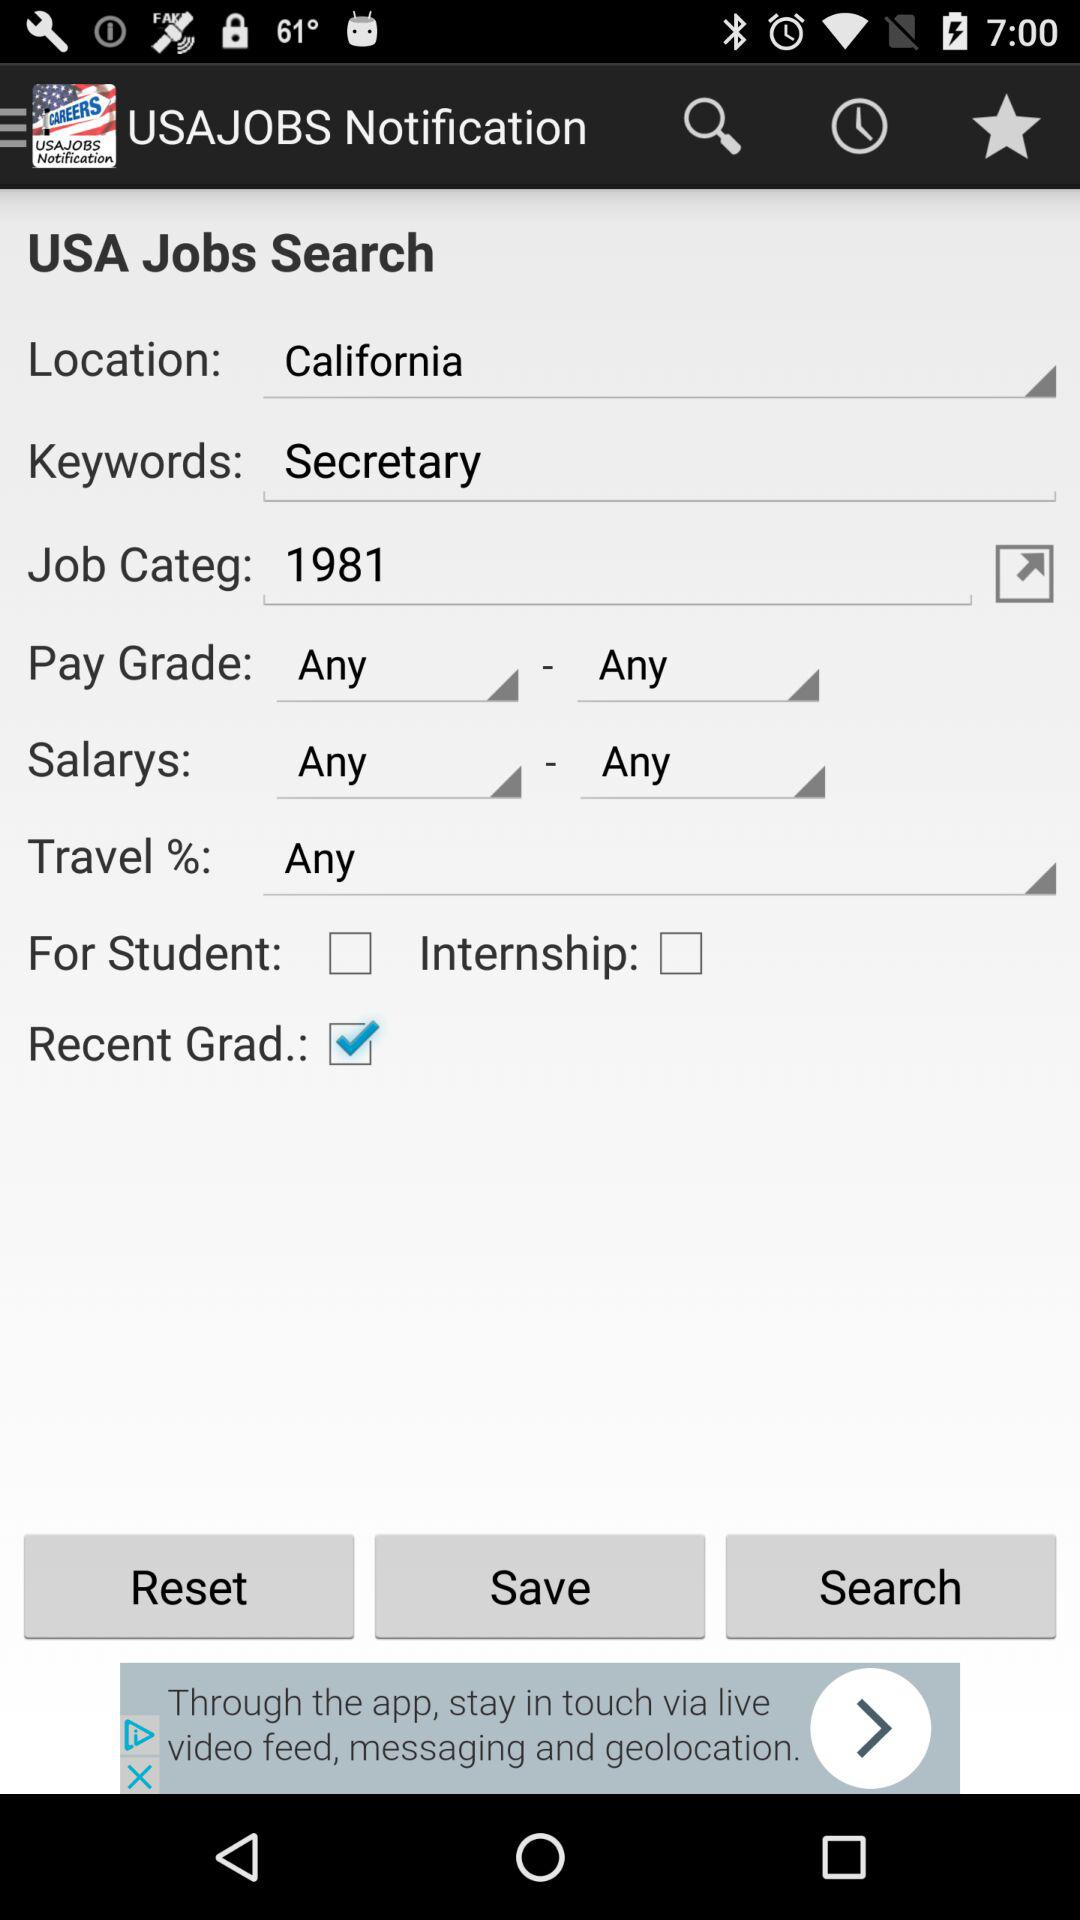What is the job category? The job category is "1981". 